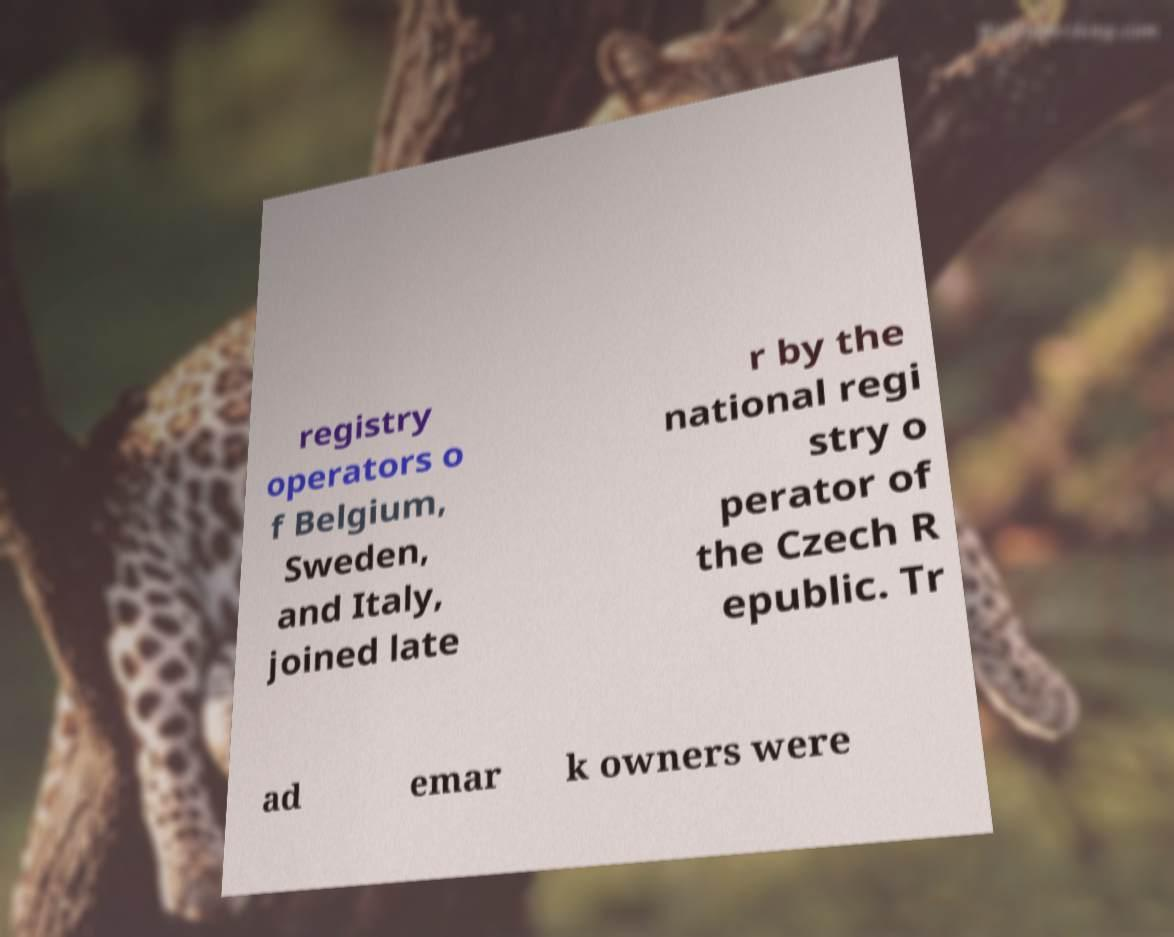Could you extract and type out the text from this image? registry operators o f Belgium, Sweden, and Italy, joined late r by the national regi stry o perator of the Czech R epublic. Tr ad emar k owners were 